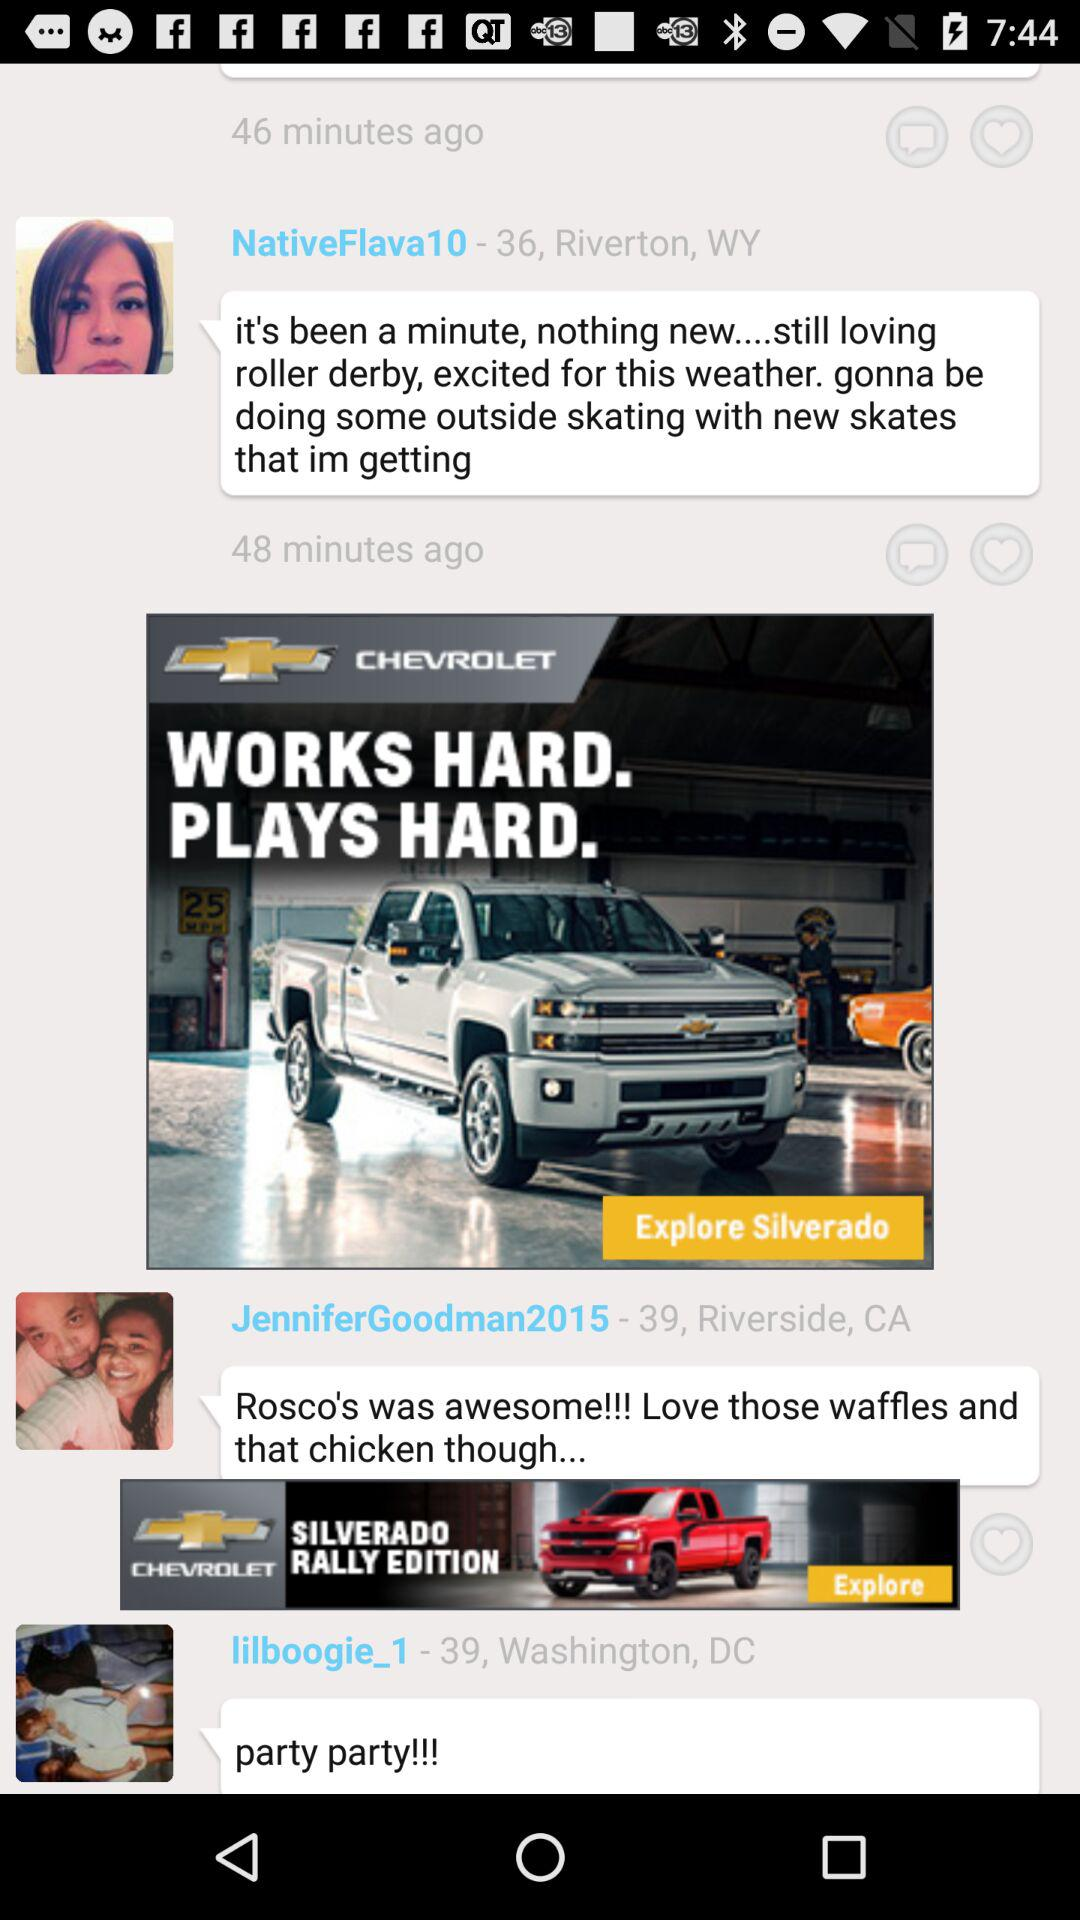How many minutes ago did NativeFlava10 post the comment? NativeFlava10 posted the comment 48 minutes ago. 